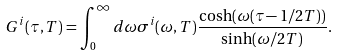Convert formula to latex. <formula><loc_0><loc_0><loc_500><loc_500>G ^ { i } ( \tau , T ) = \int _ { 0 } ^ { \infty } d \omega \sigma ^ { i } ( \omega , T ) \frac { \cosh ( \omega ( \tau - 1 / 2 T ) ) } { \sinh ( \omega / 2 T ) } .</formula> 